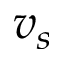Convert formula to latex. <formula><loc_0><loc_0><loc_500><loc_500>v _ { s }</formula> 